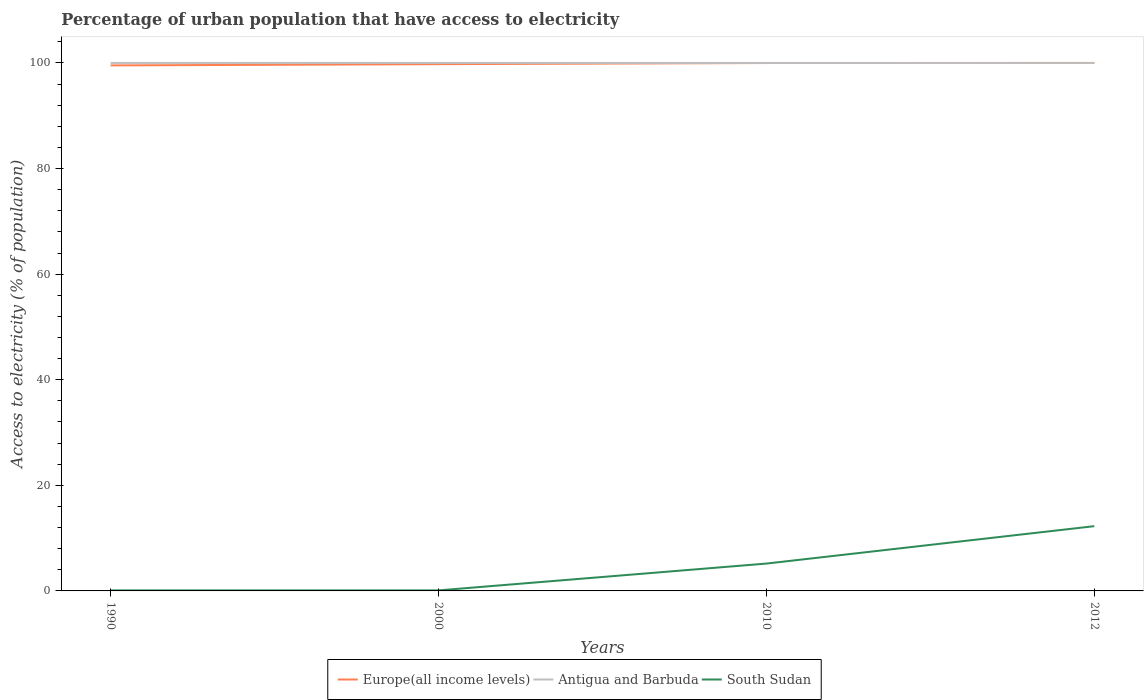How many different coloured lines are there?
Your answer should be compact. 3. Does the line corresponding to Europe(all income levels) intersect with the line corresponding to South Sudan?
Offer a terse response. No. Across all years, what is the maximum percentage of urban population that have access to electricity in South Sudan?
Your response must be concise. 0.1. What is the total percentage of urban population that have access to electricity in Europe(all income levels) in the graph?
Provide a short and direct response. -0.46. What is the difference between the highest and the second highest percentage of urban population that have access to electricity in Antigua and Barbuda?
Ensure brevity in your answer.  0. What is the difference between the highest and the lowest percentage of urban population that have access to electricity in Antigua and Barbuda?
Your answer should be very brief. 0. How many lines are there?
Keep it short and to the point. 3. What is the difference between two consecutive major ticks on the Y-axis?
Offer a terse response. 20. Are the values on the major ticks of Y-axis written in scientific E-notation?
Provide a short and direct response. No. Does the graph contain grids?
Ensure brevity in your answer.  No. How are the legend labels stacked?
Keep it short and to the point. Horizontal. What is the title of the graph?
Give a very brief answer. Percentage of urban population that have access to electricity. Does "United Kingdom" appear as one of the legend labels in the graph?
Your answer should be compact. No. What is the label or title of the X-axis?
Ensure brevity in your answer.  Years. What is the label or title of the Y-axis?
Make the answer very short. Access to electricity (% of population). What is the Access to electricity (% of population) in Europe(all income levels) in 1990?
Make the answer very short. 99.53. What is the Access to electricity (% of population) of Europe(all income levels) in 2000?
Provide a short and direct response. 99.77. What is the Access to electricity (% of population) in South Sudan in 2000?
Keep it short and to the point. 0.1. What is the Access to electricity (% of population) in Europe(all income levels) in 2010?
Ensure brevity in your answer.  99.99. What is the Access to electricity (% of population) in South Sudan in 2010?
Ensure brevity in your answer.  5.18. What is the Access to electricity (% of population) of Europe(all income levels) in 2012?
Offer a very short reply. 100. What is the Access to electricity (% of population) of South Sudan in 2012?
Provide a short and direct response. 12.27. Across all years, what is the maximum Access to electricity (% of population) in Europe(all income levels)?
Your answer should be compact. 100. Across all years, what is the maximum Access to electricity (% of population) in South Sudan?
Provide a short and direct response. 12.27. Across all years, what is the minimum Access to electricity (% of population) in Europe(all income levels)?
Your answer should be compact. 99.53. Across all years, what is the minimum Access to electricity (% of population) of Antigua and Barbuda?
Offer a terse response. 100. Across all years, what is the minimum Access to electricity (% of population) of South Sudan?
Offer a terse response. 0.1. What is the total Access to electricity (% of population) in Europe(all income levels) in the graph?
Your response must be concise. 399.29. What is the total Access to electricity (% of population) of Antigua and Barbuda in the graph?
Offer a very short reply. 400. What is the total Access to electricity (% of population) of South Sudan in the graph?
Your answer should be very brief. 17.64. What is the difference between the Access to electricity (% of population) in Europe(all income levels) in 1990 and that in 2000?
Your response must be concise. -0.24. What is the difference between the Access to electricity (% of population) in Europe(all income levels) in 1990 and that in 2010?
Provide a short and direct response. -0.45. What is the difference between the Access to electricity (% of population) in Antigua and Barbuda in 1990 and that in 2010?
Keep it short and to the point. 0. What is the difference between the Access to electricity (% of population) of South Sudan in 1990 and that in 2010?
Make the answer very short. -5.08. What is the difference between the Access to electricity (% of population) in Europe(all income levels) in 1990 and that in 2012?
Provide a succinct answer. -0.46. What is the difference between the Access to electricity (% of population) of South Sudan in 1990 and that in 2012?
Your answer should be compact. -12.17. What is the difference between the Access to electricity (% of population) in Europe(all income levels) in 2000 and that in 2010?
Give a very brief answer. -0.22. What is the difference between the Access to electricity (% of population) of South Sudan in 2000 and that in 2010?
Your response must be concise. -5.08. What is the difference between the Access to electricity (% of population) of Europe(all income levels) in 2000 and that in 2012?
Your answer should be compact. -0.23. What is the difference between the Access to electricity (% of population) of South Sudan in 2000 and that in 2012?
Provide a succinct answer. -12.17. What is the difference between the Access to electricity (% of population) of Europe(all income levels) in 2010 and that in 2012?
Offer a very short reply. -0.01. What is the difference between the Access to electricity (% of population) of South Sudan in 2010 and that in 2012?
Your answer should be very brief. -7.09. What is the difference between the Access to electricity (% of population) in Europe(all income levels) in 1990 and the Access to electricity (% of population) in Antigua and Barbuda in 2000?
Give a very brief answer. -0.47. What is the difference between the Access to electricity (% of population) in Europe(all income levels) in 1990 and the Access to electricity (% of population) in South Sudan in 2000?
Offer a very short reply. 99.43. What is the difference between the Access to electricity (% of population) in Antigua and Barbuda in 1990 and the Access to electricity (% of population) in South Sudan in 2000?
Your answer should be compact. 99.9. What is the difference between the Access to electricity (% of population) in Europe(all income levels) in 1990 and the Access to electricity (% of population) in Antigua and Barbuda in 2010?
Make the answer very short. -0.47. What is the difference between the Access to electricity (% of population) in Europe(all income levels) in 1990 and the Access to electricity (% of population) in South Sudan in 2010?
Keep it short and to the point. 94.35. What is the difference between the Access to electricity (% of population) in Antigua and Barbuda in 1990 and the Access to electricity (% of population) in South Sudan in 2010?
Make the answer very short. 94.82. What is the difference between the Access to electricity (% of population) in Europe(all income levels) in 1990 and the Access to electricity (% of population) in Antigua and Barbuda in 2012?
Your answer should be compact. -0.47. What is the difference between the Access to electricity (% of population) in Europe(all income levels) in 1990 and the Access to electricity (% of population) in South Sudan in 2012?
Your response must be concise. 87.27. What is the difference between the Access to electricity (% of population) of Antigua and Barbuda in 1990 and the Access to electricity (% of population) of South Sudan in 2012?
Offer a terse response. 87.73. What is the difference between the Access to electricity (% of population) of Europe(all income levels) in 2000 and the Access to electricity (% of population) of Antigua and Barbuda in 2010?
Your answer should be compact. -0.23. What is the difference between the Access to electricity (% of population) in Europe(all income levels) in 2000 and the Access to electricity (% of population) in South Sudan in 2010?
Offer a very short reply. 94.59. What is the difference between the Access to electricity (% of population) in Antigua and Barbuda in 2000 and the Access to electricity (% of population) in South Sudan in 2010?
Your answer should be very brief. 94.82. What is the difference between the Access to electricity (% of population) in Europe(all income levels) in 2000 and the Access to electricity (% of population) in Antigua and Barbuda in 2012?
Keep it short and to the point. -0.23. What is the difference between the Access to electricity (% of population) of Europe(all income levels) in 2000 and the Access to electricity (% of population) of South Sudan in 2012?
Make the answer very short. 87.5. What is the difference between the Access to electricity (% of population) in Antigua and Barbuda in 2000 and the Access to electricity (% of population) in South Sudan in 2012?
Offer a terse response. 87.73. What is the difference between the Access to electricity (% of population) in Europe(all income levels) in 2010 and the Access to electricity (% of population) in Antigua and Barbuda in 2012?
Make the answer very short. -0.01. What is the difference between the Access to electricity (% of population) of Europe(all income levels) in 2010 and the Access to electricity (% of population) of South Sudan in 2012?
Your answer should be compact. 87.72. What is the difference between the Access to electricity (% of population) in Antigua and Barbuda in 2010 and the Access to electricity (% of population) in South Sudan in 2012?
Your response must be concise. 87.73. What is the average Access to electricity (% of population) of Europe(all income levels) per year?
Keep it short and to the point. 99.82. What is the average Access to electricity (% of population) in Antigua and Barbuda per year?
Your answer should be very brief. 100. What is the average Access to electricity (% of population) of South Sudan per year?
Your answer should be very brief. 4.41. In the year 1990, what is the difference between the Access to electricity (% of population) of Europe(all income levels) and Access to electricity (% of population) of Antigua and Barbuda?
Make the answer very short. -0.47. In the year 1990, what is the difference between the Access to electricity (% of population) in Europe(all income levels) and Access to electricity (% of population) in South Sudan?
Provide a succinct answer. 99.43. In the year 1990, what is the difference between the Access to electricity (% of population) of Antigua and Barbuda and Access to electricity (% of population) of South Sudan?
Make the answer very short. 99.9. In the year 2000, what is the difference between the Access to electricity (% of population) of Europe(all income levels) and Access to electricity (% of population) of Antigua and Barbuda?
Keep it short and to the point. -0.23. In the year 2000, what is the difference between the Access to electricity (% of population) of Europe(all income levels) and Access to electricity (% of population) of South Sudan?
Provide a short and direct response. 99.67. In the year 2000, what is the difference between the Access to electricity (% of population) of Antigua and Barbuda and Access to electricity (% of population) of South Sudan?
Provide a short and direct response. 99.9. In the year 2010, what is the difference between the Access to electricity (% of population) in Europe(all income levels) and Access to electricity (% of population) in Antigua and Barbuda?
Offer a very short reply. -0.01. In the year 2010, what is the difference between the Access to electricity (% of population) in Europe(all income levels) and Access to electricity (% of population) in South Sudan?
Give a very brief answer. 94.81. In the year 2010, what is the difference between the Access to electricity (% of population) of Antigua and Barbuda and Access to electricity (% of population) of South Sudan?
Offer a terse response. 94.82. In the year 2012, what is the difference between the Access to electricity (% of population) of Europe(all income levels) and Access to electricity (% of population) of Antigua and Barbuda?
Offer a very short reply. -0. In the year 2012, what is the difference between the Access to electricity (% of population) in Europe(all income levels) and Access to electricity (% of population) in South Sudan?
Offer a very short reply. 87.73. In the year 2012, what is the difference between the Access to electricity (% of population) of Antigua and Barbuda and Access to electricity (% of population) of South Sudan?
Provide a short and direct response. 87.73. What is the ratio of the Access to electricity (% of population) in Europe(all income levels) in 1990 to that in 2000?
Offer a very short reply. 1. What is the ratio of the Access to electricity (% of population) of Antigua and Barbuda in 1990 to that in 2000?
Your answer should be very brief. 1. What is the ratio of the Access to electricity (% of population) of Europe(all income levels) in 1990 to that in 2010?
Offer a very short reply. 1. What is the ratio of the Access to electricity (% of population) of South Sudan in 1990 to that in 2010?
Your answer should be compact. 0.02. What is the ratio of the Access to electricity (% of population) of Antigua and Barbuda in 1990 to that in 2012?
Your answer should be very brief. 1. What is the ratio of the Access to electricity (% of population) in South Sudan in 1990 to that in 2012?
Provide a short and direct response. 0.01. What is the ratio of the Access to electricity (% of population) in Europe(all income levels) in 2000 to that in 2010?
Give a very brief answer. 1. What is the ratio of the Access to electricity (% of population) of Antigua and Barbuda in 2000 to that in 2010?
Your answer should be compact. 1. What is the ratio of the Access to electricity (% of population) in South Sudan in 2000 to that in 2010?
Give a very brief answer. 0.02. What is the ratio of the Access to electricity (% of population) of South Sudan in 2000 to that in 2012?
Give a very brief answer. 0.01. What is the ratio of the Access to electricity (% of population) of Europe(all income levels) in 2010 to that in 2012?
Ensure brevity in your answer.  1. What is the ratio of the Access to electricity (% of population) in Antigua and Barbuda in 2010 to that in 2012?
Keep it short and to the point. 1. What is the ratio of the Access to electricity (% of population) in South Sudan in 2010 to that in 2012?
Your answer should be compact. 0.42. What is the difference between the highest and the second highest Access to electricity (% of population) in Europe(all income levels)?
Provide a succinct answer. 0.01. What is the difference between the highest and the second highest Access to electricity (% of population) of Antigua and Barbuda?
Make the answer very short. 0. What is the difference between the highest and the second highest Access to electricity (% of population) in South Sudan?
Provide a succinct answer. 7.09. What is the difference between the highest and the lowest Access to electricity (% of population) in Europe(all income levels)?
Your answer should be compact. 0.46. What is the difference between the highest and the lowest Access to electricity (% of population) of South Sudan?
Give a very brief answer. 12.17. 